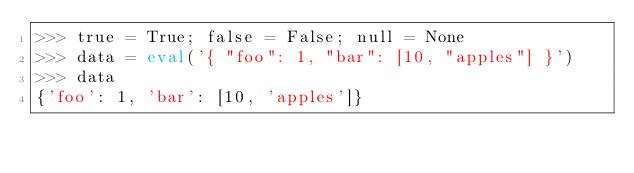Convert code to text. <code><loc_0><loc_0><loc_500><loc_500><_Python_>>>> true = True; false = False; null = None
>>> data = eval('{ "foo": 1, "bar": [10, "apples"] }')
>>> data
{'foo': 1, 'bar': [10, 'apples']}
</code> 